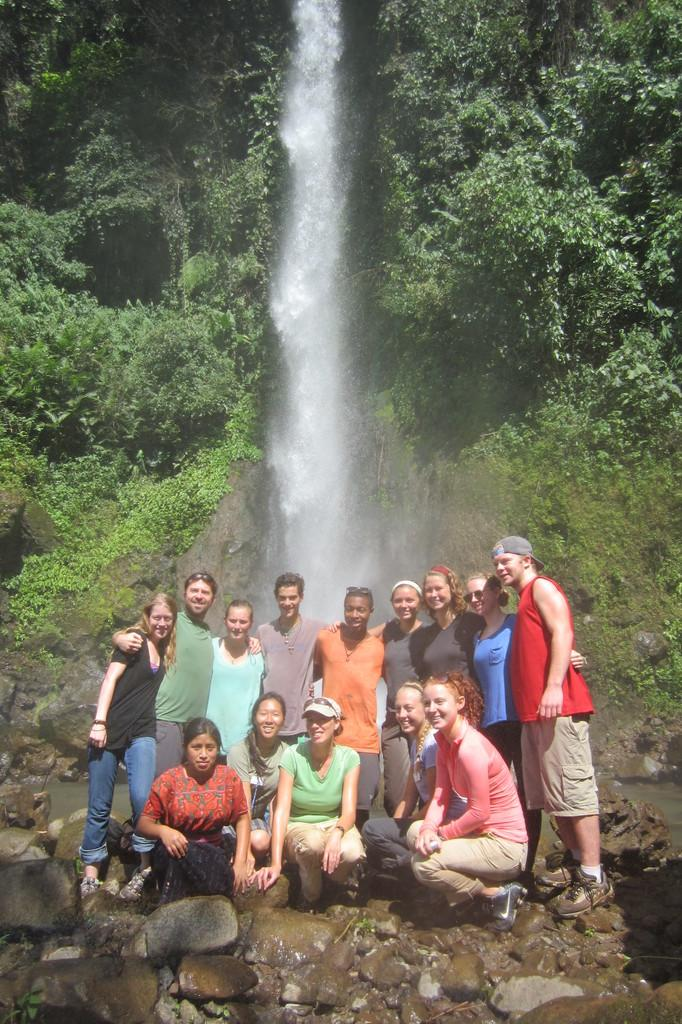How many people are in the image? There is a group of people in the image. What are the people in the image doing? Some people are standing, while others are sitting on stones. What can be seen in the background of the image? Trees and water are visible in the background of the image. What type of quince can be seen on the shelf in the image? There is no quince or shelf present in the image. How many heads are visible in the image? The question cannot be answered definitively from the provided facts, as the number of visible heads is not mentioned. 